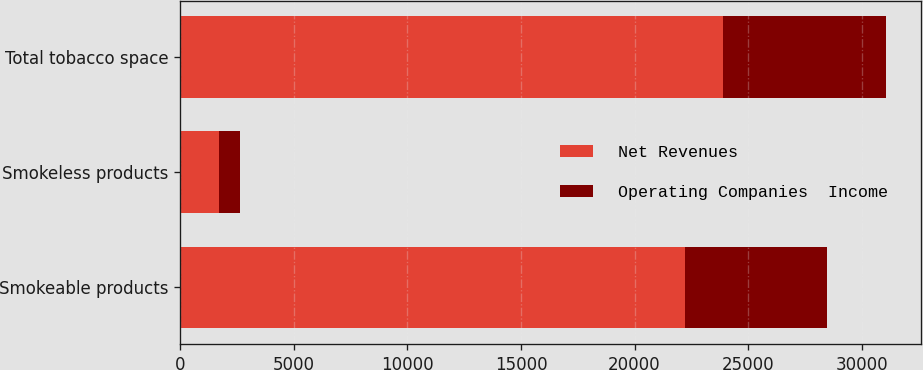Convert chart to OTSL. <chart><loc_0><loc_0><loc_500><loc_500><stacked_bar_chart><ecel><fcel>Smokeable products<fcel>Smokeless products<fcel>Total tobacco space<nl><fcel>Net Revenues<fcel>22216<fcel>1691<fcel>23907<nl><fcel>Operating Companies  Income<fcel>6239<fcel>931<fcel>7170<nl></chart> 